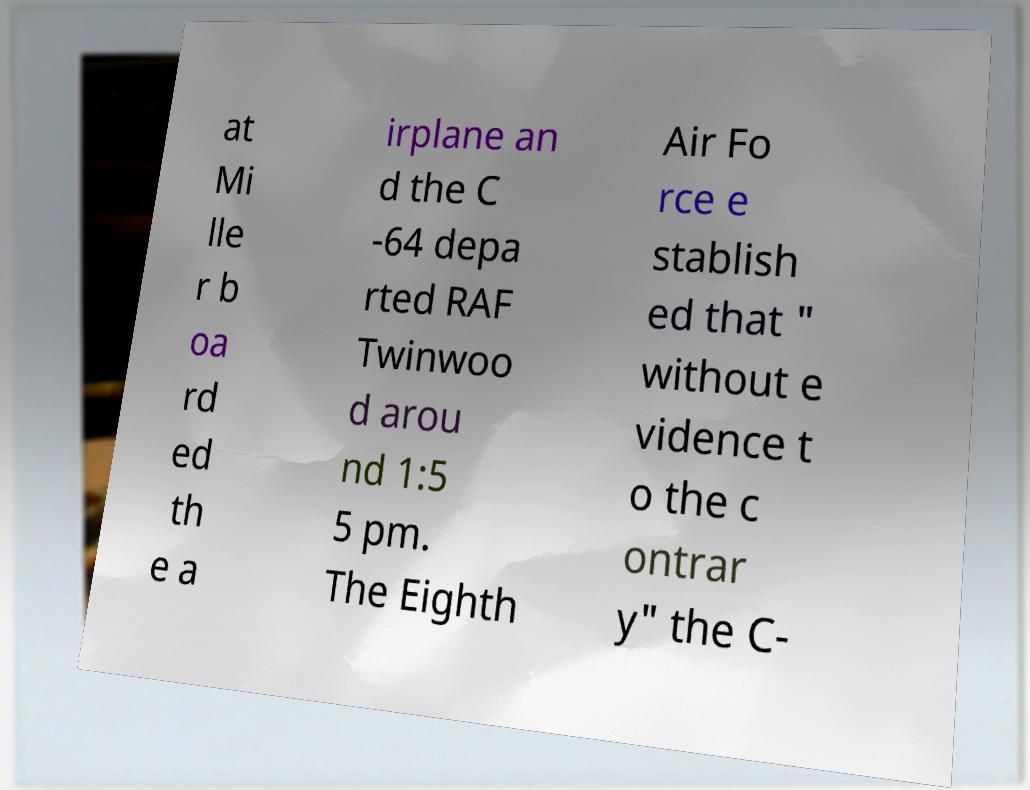Can you read and provide the text displayed in the image?This photo seems to have some interesting text. Can you extract and type it out for me? at Mi lle r b oa rd ed th e a irplane an d the C -64 depa rted RAF Twinwoo d arou nd 1:5 5 pm. The Eighth Air Fo rce e stablish ed that " without e vidence t o the c ontrar y" the C- 